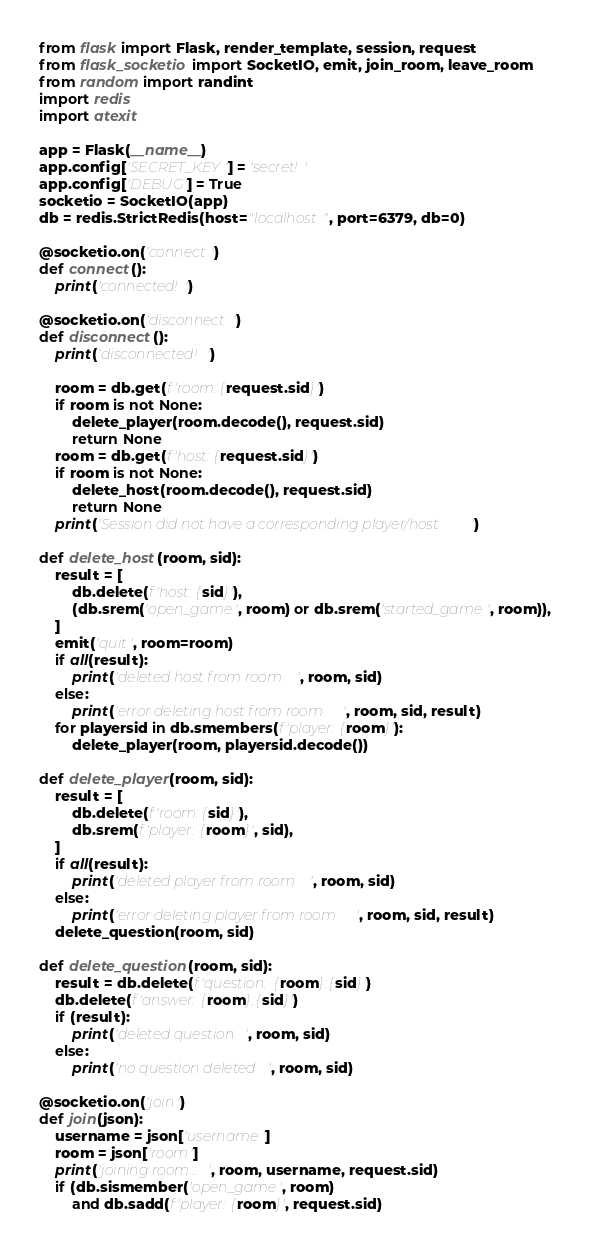Convert code to text. <code><loc_0><loc_0><loc_500><loc_500><_Python_>from flask import Flask, render_template, session, request
from flask_socketio import SocketIO, emit, join_room, leave_room
from random import randint
import redis
import atexit

app = Flask(__name__)
app.config['SECRET_KEY'] = 'secret!'
app.config['DEBUG'] = True
socketio = SocketIO(app)
db = redis.StrictRedis(host="localhost", port=6379, db=0)

@socketio.on('connect')
def connect():
    print('connected!')

@socketio.on('disconnect')
def disconnect():
    print('disconnected!')

    room = db.get(f'room:{request.sid}')
    if room is not None:
        delete_player(room.decode(), request.sid)
        return None
    room = db.get(f'host:{request.sid}')
    if room is not None:
        delete_host(room.decode(), request.sid)
        return None
    print('Session did not have a corresponding player/host')

def delete_host(room, sid):
    result = [
        db.delete(f'host:{sid}'),
        (db.srem('open_game', room) or db.srem('started_game', room)),
    ]
    emit('quit', room=room)
    if all(result):
        print('deleted host from room', room, sid)
    else:
        print('error deleting host from room', room, sid, result)
    for playersid in db.smembers(f'player:{room}'):
        delete_player(room, playersid.decode())

def delete_player(room, sid):
    result = [
        db.delete(f'room:{sid}'),
        db.srem(f'player:{room}', sid),
    ]
    if all(result):
        print('deleted player from room', room, sid)
    else:
        print('error deleting player from room', room, sid, result)
    delete_question(room, sid)

def delete_question(room, sid):
    result = db.delete(f'question:{room}:{sid}')
    db.delete(f'answer:{room}:{sid}')
    if (result):
        print('deleted question', room, sid)
    else:
        print('no question deleted', room, sid)
        
@socketio.on('join')
def join(json):
    username = json['username']
    room = json['room']
    print('joining room...', room, username, request.sid)
    if (db.sismember('open_game', room)
        and db.sadd(f'player:{room}', request.sid)</code> 